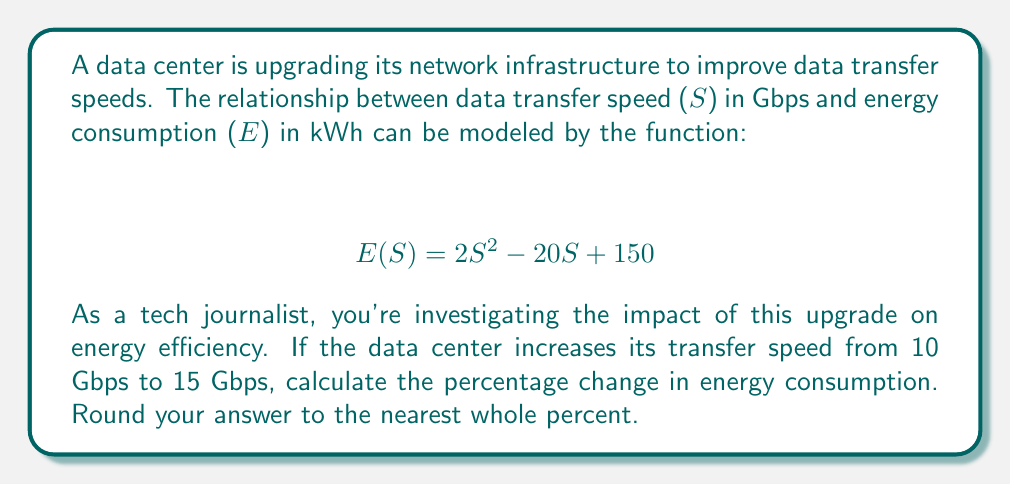Help me with this question. To solve this problem, we'll follow these steps:

1. Calculate the energy consumption at 10 Gbps
2. Calculate the energy consumption at 15 Gbps
3. Calculate the difference in energy consumption
4. Calculate the percentage change

Step 1: Energy consumption at 10 Gbps
$$ E(10) = 2(10)^2 - 20(10) + 150 $$
$$ E(10) = 200 - 200 + 150 = 150 \text{ kWh} $$

Step 2: Energy consumption at 15 Gbps
$$ E(15) = 2(15)^2 - 20(15) + 150 $$
$$ E(15) = 450 - 300 + 150 = 300 \text{ kWh} $$

Step 3: Difference in energy consumption
$$ \text{Difference} = E(15) - E(10) = 300 - 150 = 150 \text{ kWh} $$

Step 4: Percentage change
$$ \text{Percentage change} = \frac{\text{Difference}}{\text{Initial value}} \times 100\% $$
$$ = \frac{150}{150} \times 100\% = 100\% $$

Therefore, the percentage change in energy consumption is 100%.
Answer: 100% 